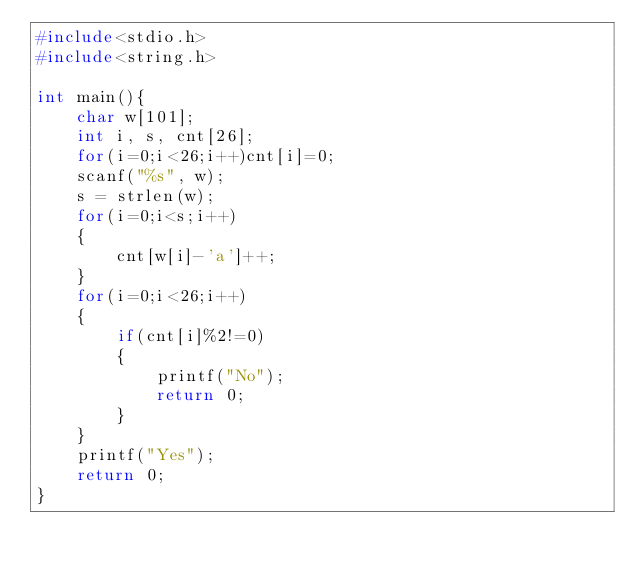Convert code to text. <code><loc_0><loc_0><loc_500><loc_500><_C_>#include<stdio.h>
#include<string.h>

int main(){
    char w[101];
    int i, s, cnt[26];
    for(i=0;i<26;i++)cnt[i]=0;
    scanf("%s", w);
    s = strlen(w);
    for(i=0;i<s;i++)
    {
        cnt[w[i]-'a']++;
    }
    for(i=0;i<26;i++)
    {
        if(cnt[i]%2!=0)
        {
            printf("No");
            return 0;
        }
    }
    printf("Yes");
    return 0;
}
</code> 